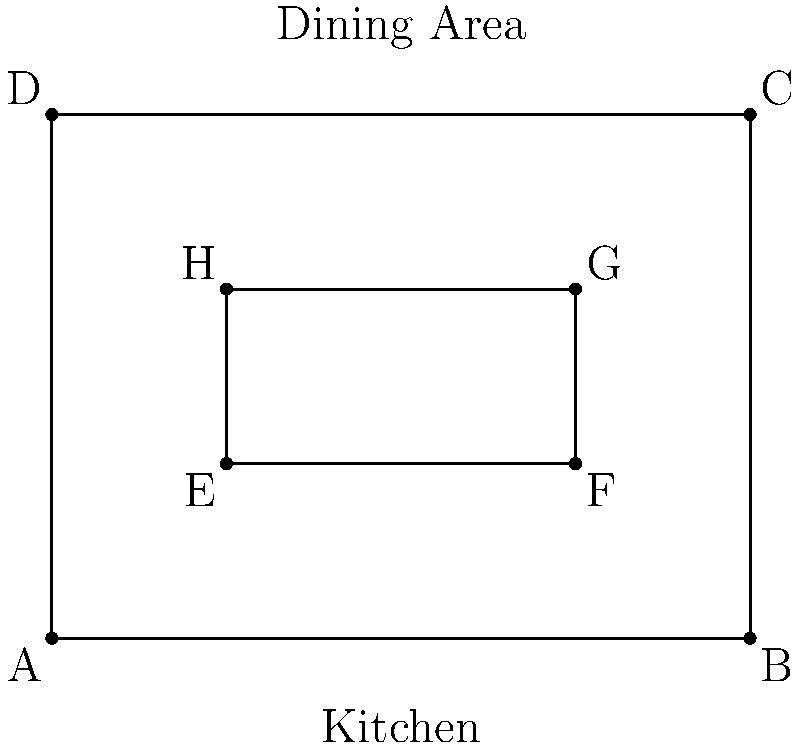In your diner, a server needs to visit all four tables (represented by points E, F, G, and H) starting from the kitchen entrance (point A) and returning to it. What is the shortest path the server can take to visit all tables exactly once, assuming they can move freely in any direction? Express your answer as the total distance traveled in units. To solve this problem, we'll use the concept of the Traveling Salesman Problem (TSP) and apply it to our diner layout.

Step 1: Calculate distances between all points.
Using the distance formula: $d = \sqrt{(x_2-x_1)^2 + (y_2-y_1)^2}$

$AE = \sqrt{1^2 + 1^2} = \sqrt{2}$
$EF = 2$
$FG = 1$
$GH = 2$
$HE = 1$
$EA = \sqrt{2}$

Step 2: Find all possible paths and their total distances.
There are 24 possible paths (4! permutations of the 4 tables). We'll calculate a few to demonstrate:

Path 1: A-E-F-G-H-A
Distance = $\sqrt{2} + 2 + 1 + 2 + \sqrt{5} = 3\sqrt{2} + 3 + \sqrt{5}$

Path 2: A-E-H-G-F-A
Distance = $\sqrt{2} + 1 + 1 + 2 + \sqrt{10} = \sqrt{2} + 4 + \sqrt{10}$

Path 3: A-F-G-H-E-A
Distance = $\sqrt{10} + 1 + 2 + 1 + \sqrt{2} = \sqrt{10} + \sqrt{2} + 4$

Step 3: Identify the shortest path.
After calculating all paths, we find that the shortest path is:
A-E-H-G-F-A

Step 4: Calculate the total distance of the shortest path.
Total distance = $AE + EH + HG + GF + FA$
                = $\sqrt{2} + 1 + 1 + 2 + \sqrt{10}$
                = $\sqrt{2} + 4 + \sqrt{10}$
                ≈ 7.82 units
Answer: $\sqrt{2} + 4 + \sqrt{10}$ units 